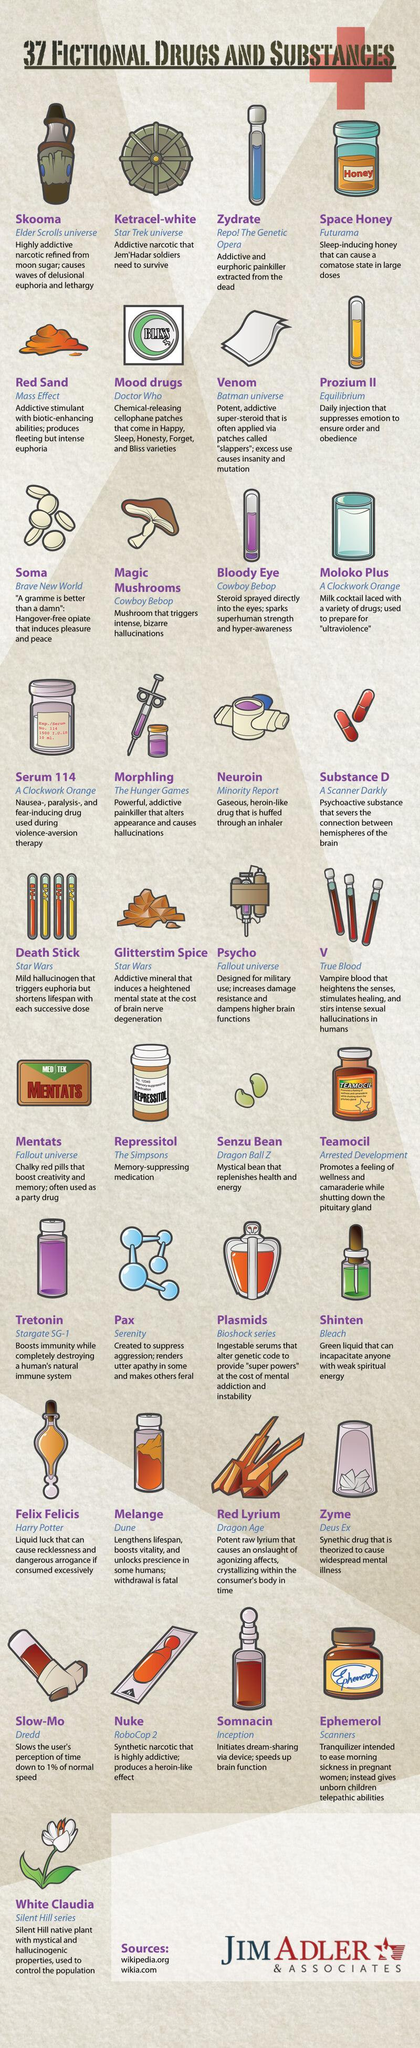Which fictional drug is administered as a daily injection to suppress emotion to ensure order and obedience?
Answer the question with a short phrase. prozium ii Which fictional drug is mentioned in The Hunger Games? morphling Which is the highly addictive narcotic refined from moon sugar? skooma Which drug is extracted from the dead? zydrate Which fictional drug slows the user's perception of time down to 1% of normal speed? slow-mo Which drug is used for memory-suppressing? repressitol Which drug from Fallout Universe is designed for military use? psycho In which fictional work is the drug Ephemerol mentioned? scanners Which drug from A Clockwork Orange is mentioned? serum 114 Which drug is used as liquid luck in Harry Potter? felix felicis 